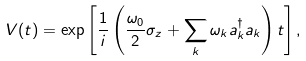Convert formula to latex. <formula><loc_0><loc_0><loc_500><loc_500>V ( t ) = \exp \left [ \frac { 1 } { i } \left ( \frac { \omega _ { 0 } } { 2 } \sigma _ { z } + \sum _ { k } \omega _ { k } a ^ { \dagger } _ { k } a _ { k } \right ) t \right ] ,</formula> 